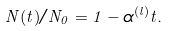<formula> <loc_0><loc_0><loc_500><loc_500>N ( t ) / N _ { 0 } = 1 - \alpha ^ { ( l ) } t .</formula> 